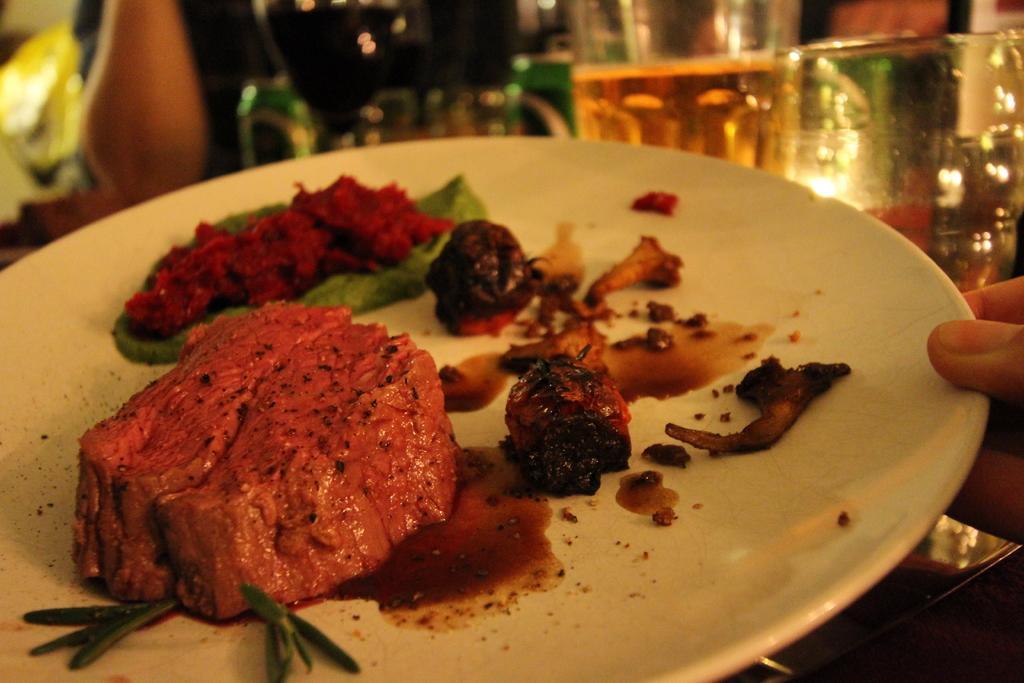Describe this image in one or two sentences. In this image we can see a plate with food item. And we can see fingers of a person holding the plate. Also there are glasses. And it is looking blur in the background. 